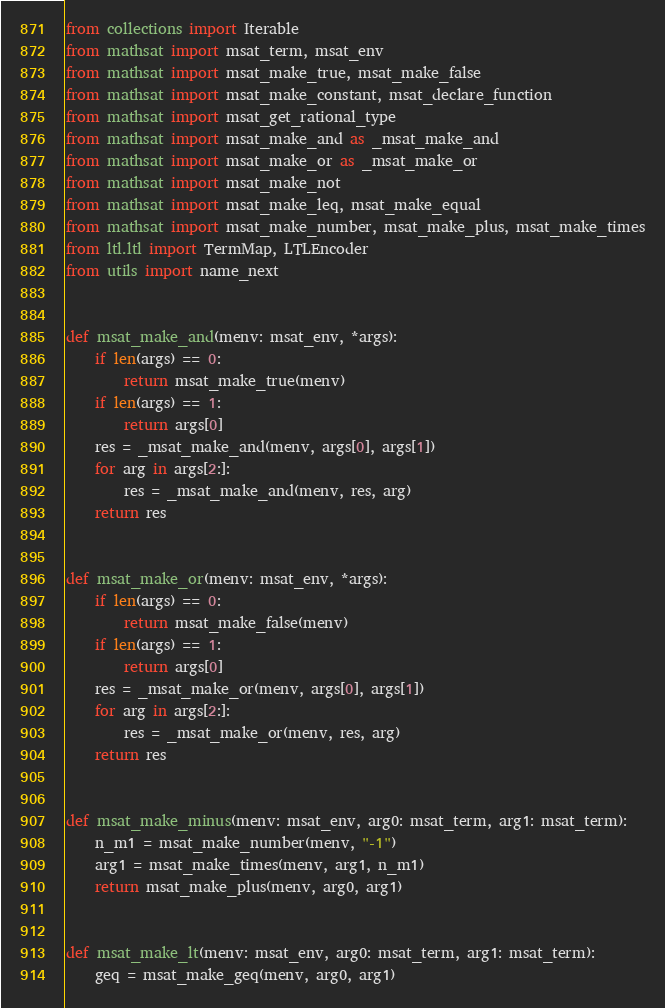<code> <loc_0><loc_0><loc_500><loc_500><_Python_>
from collections import Iterable
from mathsat import msat_term, msat_env
from mathsat import msat_make_true, msat_make_false
from mathsat import msat_make_constant, msat_declare_function
from mathsat import msat_get_rational_type
from mathsat import msat_make_and as _msat_make_and
from mathsat import msat_make_or as _msat_make_or
from mathsat import msat_make_not
from mathsat import msat_make_leq, msat_make_equal
from mathsat import msat_make_number, msat_make_plus, msat_make_times
from ltl.ltl import TermMap, LTLEncoder
from utils import name_next


def msat_make_and(menv: msat_env, *args):
    if len(args) == 0:
        return msat_make_true(menv)
    if len(args) == 1:
        return args[0]
    res = _msat_make_and(menv, args[0], args[1])
    for arg in args[2:]:
        res = _msat_make_and(menv, res, arg)
    return res


def msat_make_or(menv: msat_env, *args):
    if len(args) == 0:
        return msat_make_false(menv)
    if len(args) == 1:
        return args[0]
    res = _msat_make_or(menv, args[0], args[1])
    for arg in args[2:]:
        res = _msat_make_or(menv, res, arg)
    return res


def msat_make_minus(menv: msat_env, arg0: msat_term, arg1: msat_term):
    n_m1 = msat_make_number(menv, "-1")
    arg1 = msat_make_times(menv, arg1, n_m1)
    return msat_make_plus(menv, arg0, arg1)


def msat_make_lt(menv: msat_env, arg0: msat_term, arg1: msat_term):
    geq = msat_make_geq(menv, arg0, arg1)</code> 